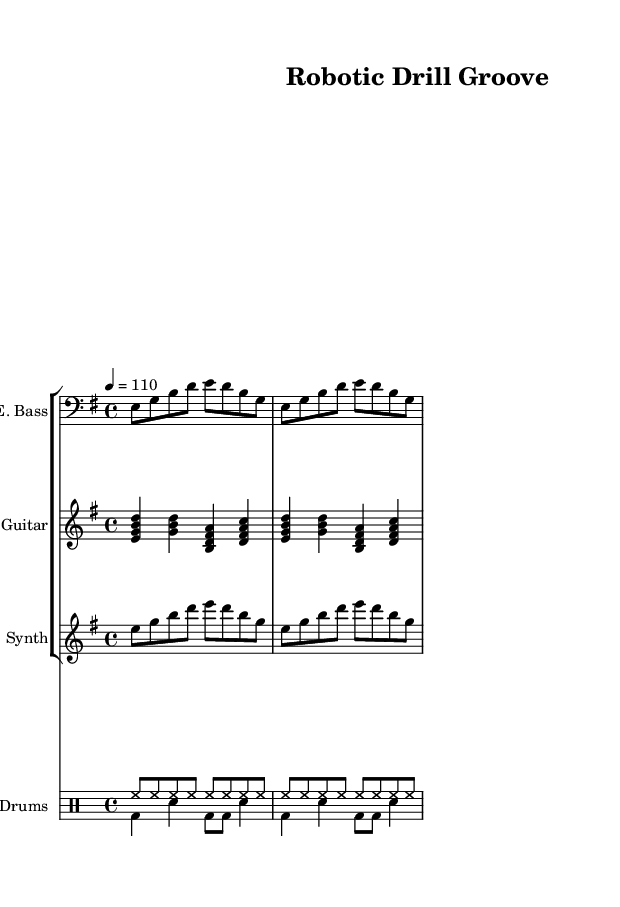What is the key signature of this music? The key signature is E minor, as indicated by the one sharp (F#) shown on the left side of the staff.
Answer: E minor What is the time signature of this music? The time signature is 4/4, which is displayed at the beginning of the score, indicating four beats per measure.
Answer: 4/4 What is the tempo marking in this piece? The tempo marking is set to 110 beats per minute, as indicated in the tempo instruction "4 = 110" at the start of the piece.
Answer: 110 How many measures does the electric bass part repeat? The electric bass part has a repeated section, indicated by "repeat unfold 2," meaning it repeats for 2 measures.
Answer: 2 Which instrument plays the chord progressions in this composition? The electric guitar plays the chord progressions, shown through the chord notation in the staff relative to the guitar part.
Answer: Electric Guitar Name a defining characteristic of Funk music observed in this piece. The strong emphasis on syncopated rhythms and the use of bass lines prominent in the electric bass part are typical characteristics of Funk music.
Answer: Syncopated Rhythms How many voices are used in the drum part? The drum part consists of two voices, as shown by the two distinct DrumVoice notations in the score.
Answer: Two 